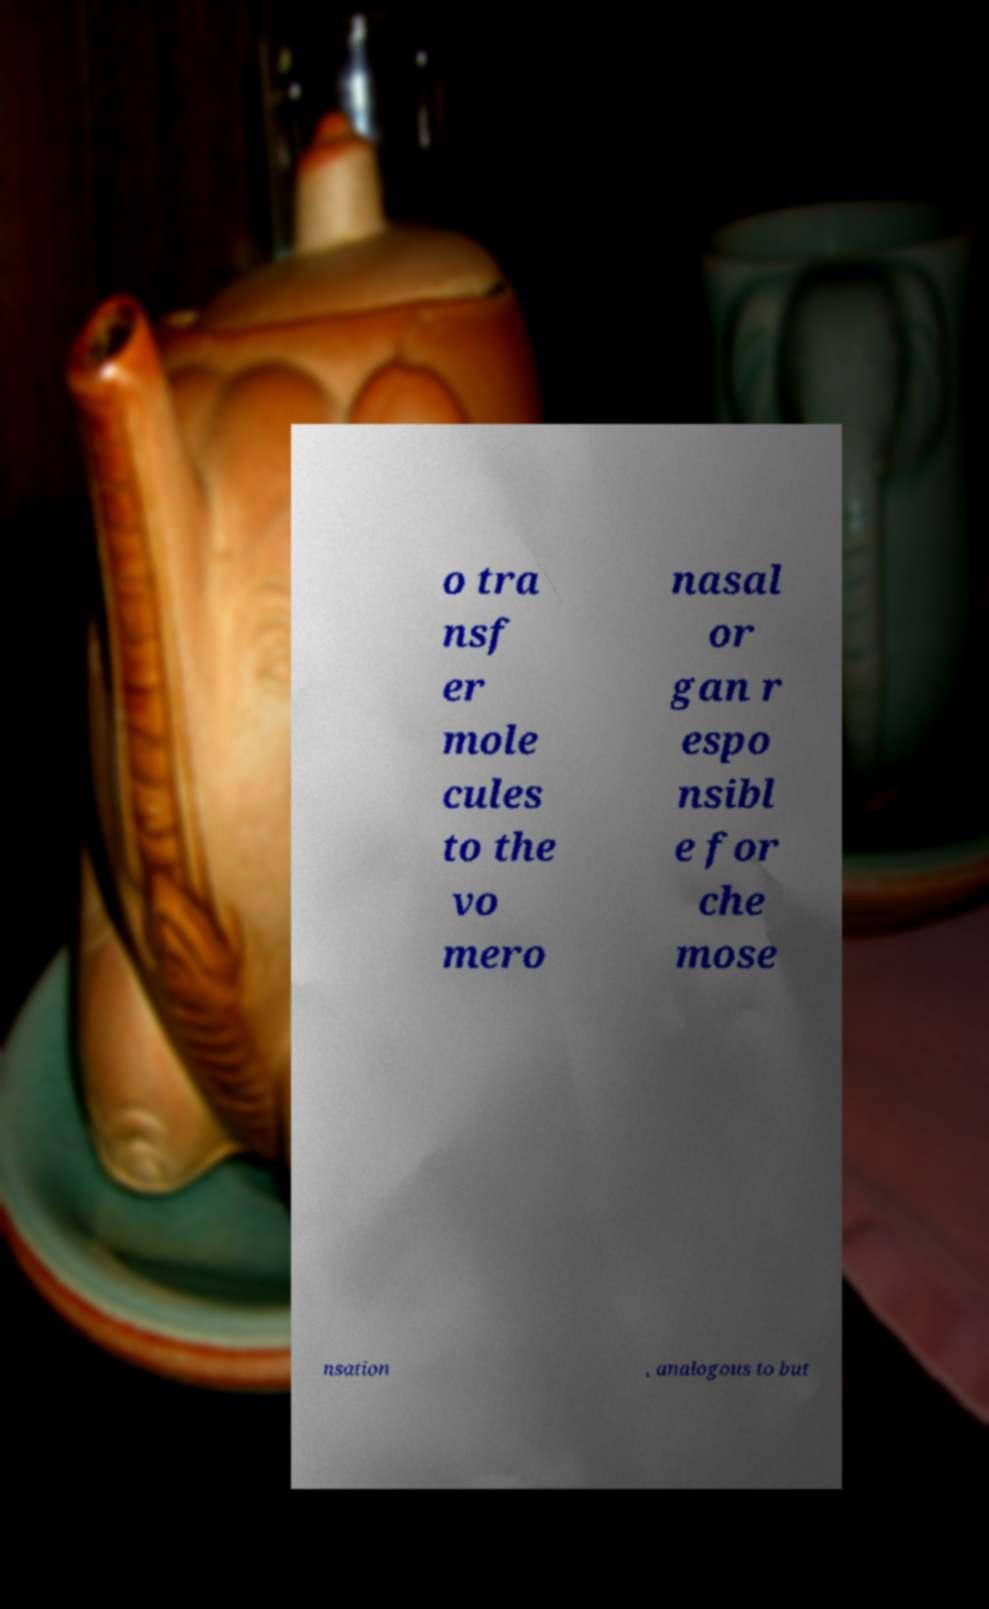For documentation purposes, I need the text within this image transcribed. Could you provide that? o tra nsf er mole cules to the vo mero nasal or gan r espo nsibl e for che mose nsation , analogous to but 